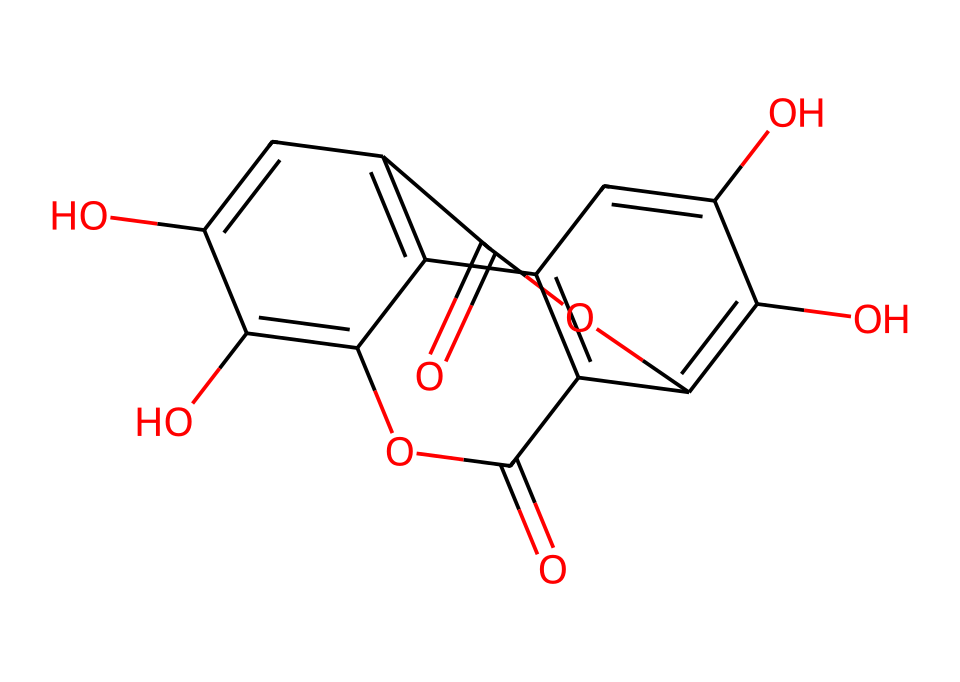how many hydroxyl groups are present in this chemical structure? The structure includes multiple –OH groups, which are characteristic of phenols. By examining the structure closely, we identify three –OH (hydroxyl) groups located on the aromatic rings.
Answer: three what is the basic functional group of this molecule? This molecule's structure contains several –OH groups attached to a benzene ring, which is the defining feature of phenols. Therefore, the main functional group is the hydroxyl group.
Answer: hydroxyl what is the total number of carbon atoms in the structure? By counting the carbon atoms in the skeletal structure provided by the SMILES representation, we find that there are thirteen carbon atoms in total throughout the chemical structure.
Answer: thirteen what type of bond primarily connects the carbon atoms in this structure? The carbon atoms in the structure are primarily interconnected by single covalent bonds and a few double covalent bonds, as indicated by the presence of carbon-carbon connections in the aromatic rings and some carbonyl groups.
Answer: covalent what type of resonance structure can be observed in this phenolic compound? The compound exhibits resonance due to the alternating double bonds in the aromatic rings, allowing for delocalization of π electrons across the structure, which stabilizes the molecule.
Answer: resonance how many rings are present in the chemical structure? By analyzing the structure, we can identify that there are two benzene-like fused rings in the molecule, characteristic of phenolic compounds.
Answer: two what is the effect of hydroxyl groups on the solubility of this compound? The presence of multiple hydroxyl groups increases the solubility of the compound in water due to the ability to form hydrogen bonds with water molecules. This is a common trait of phenol compounds.
Answer: increases 